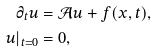Convert formula to latex. <formula><loc_0><loc_0><loc_500><loc_500>\partial _ { t } u & = \mathcal { A } u + f ( x , t ) , \\ u | _ { t = 0 } & = 0 ,</formula> 